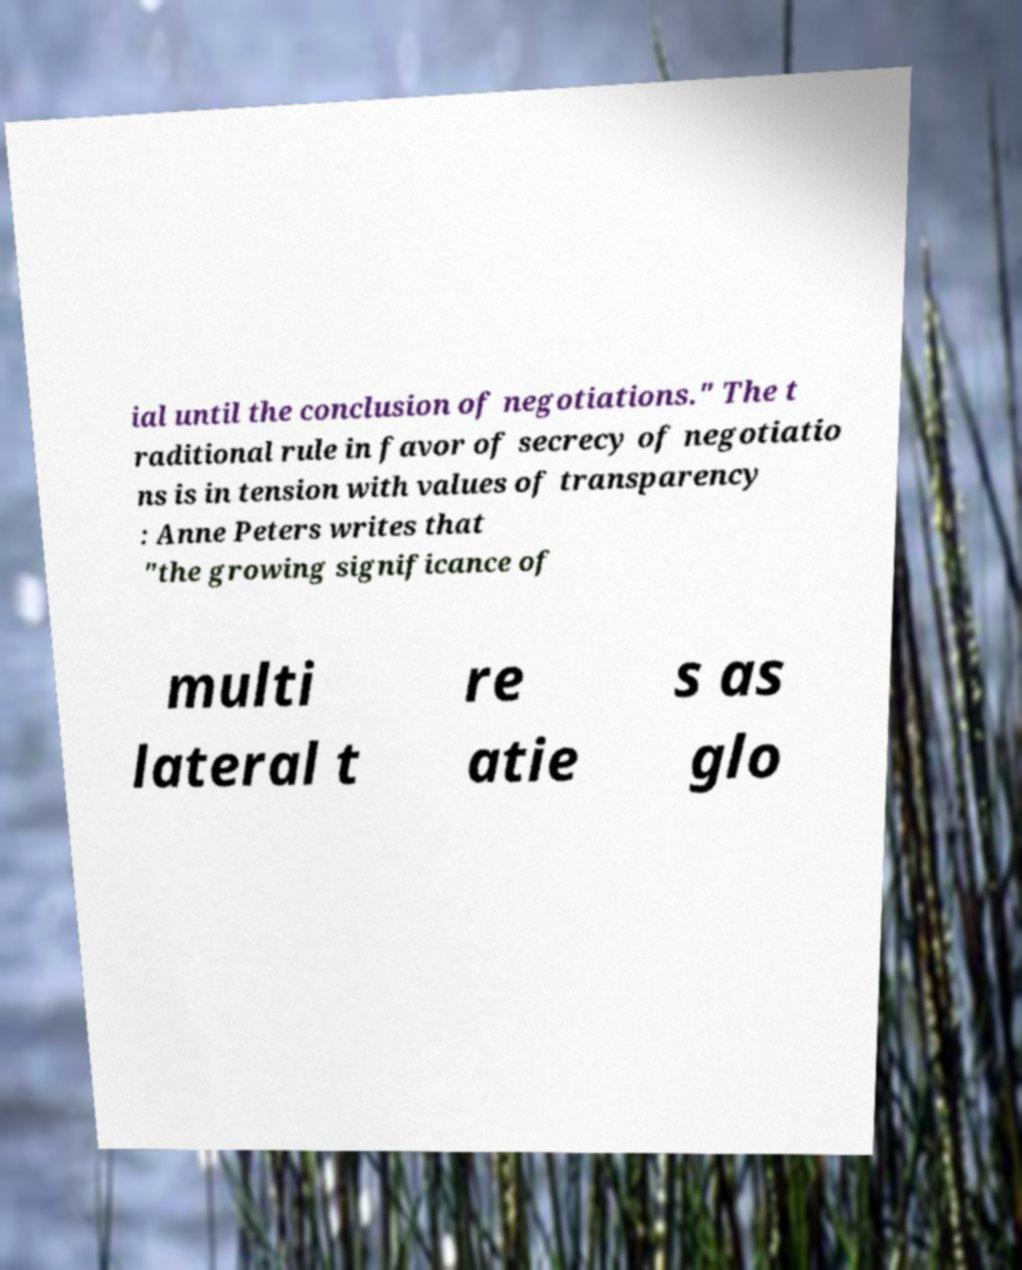Please read and relay the text visible in this image. What does it say? ial until the conclusion of negotiations." The t raditional rule in favor of secrecy of negotiatio ns is in tension with values of transparency : Anne Peters writes that "the growing significance of multi lateral t re atie s as glo 